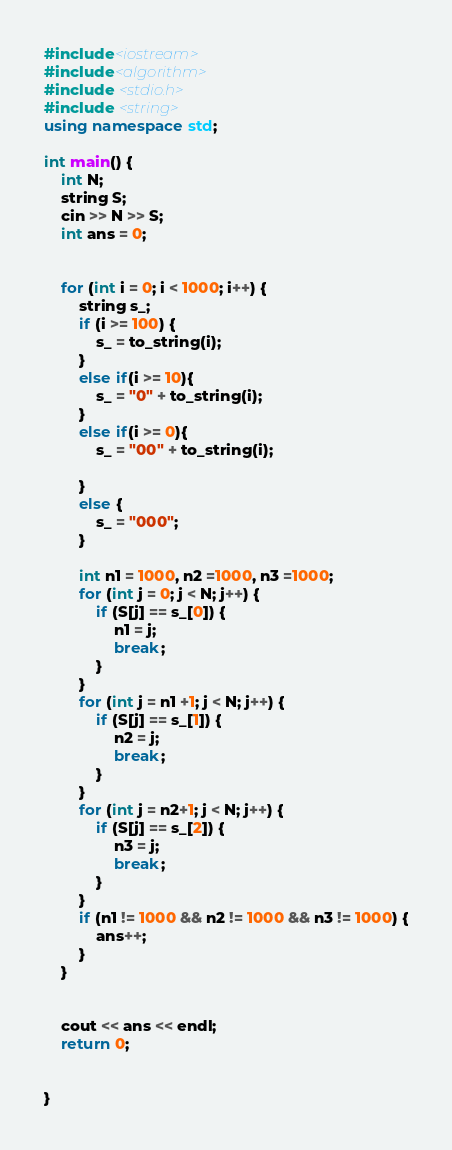Convert code to text. <code><loc_0><loc_0><loc_500><loc_500><_C++_>#include<iostream>
#include<algorithm>
#include <stdio.h>
#include <string>
using namespace std;

int main() {
	int N;
	string S;
	cin >> N >> S;
	int ans = 0;


	for (int i = 0; i < 1000; i++) {
		string s_;
		if (i >= 100) {
			s_ = to_string(i);
		}
		else if(i >= 10){
			s_ = "0" + to_string(i);
		}
		else if(i >= 0){
			s_ = "00" + to_string(i);

		}
		else {
			s_ = "000";
		}
		
		int n1 = 1000, n2 =1000, n3 =1000;
		for (int j = 0; j < N; j++) {
			if (S[j] == s_[0]) {
				n1 = j;
				break;
			}
		}
		for (int j = n1 +1; j < N; j++) {
			if (S[j] == s_[1]) {
				n2 = j;
				break;
			}
		}
		for (int j = n2+1; j < N; j++) {
			if (S[j] == s_[2]) {
				n3 = j;
				break;
			}
		}
		if (n1 != 1000 && n2 != 1000 && n3 != 1000) {
			ans++;
		}
	}


	cout << ans << endl;
	return 0;


}</code> 